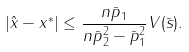<formula> <loc_0><loc_0><loc_500><loc_500>| \hat { x } - x ^ { * } | \leq \frac { n \| \bar { p } \| _ { 1 } } { n \| \bar { p } \| _ { 2 } ^ { 2 } - \| \bar { p } \| _ { 1 } ^ { 2 } } V ( \bar { s } ) .</formula> 